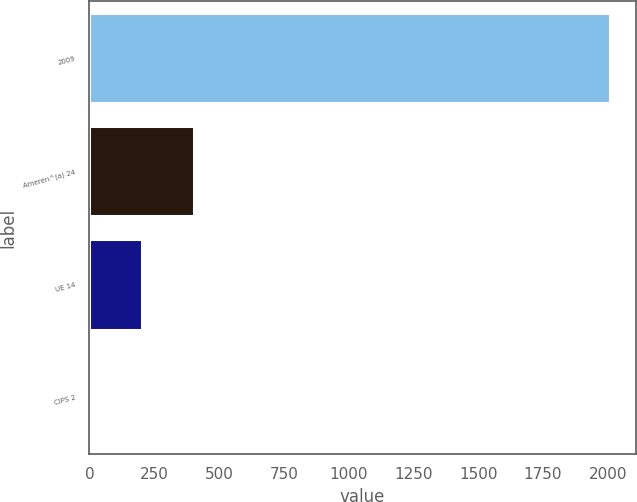Convert chart. <chart><loc_0><loc_0><loc_500><loc_500><bar_chart><fcel>2009<fcel>Ameren^(a) 24<fcel>UE 14<fcel>CIPS 2<nl><fcel>2008<fcel>403.2<fcel>202.6<fcel>2<nl></chart> 